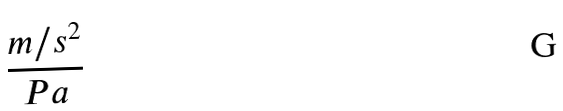Convert formula to latex. <formula><loc_0><loc_0><loc_500><loc_500>\frac { m / s ^ { 2 } } { P a }</formula> 